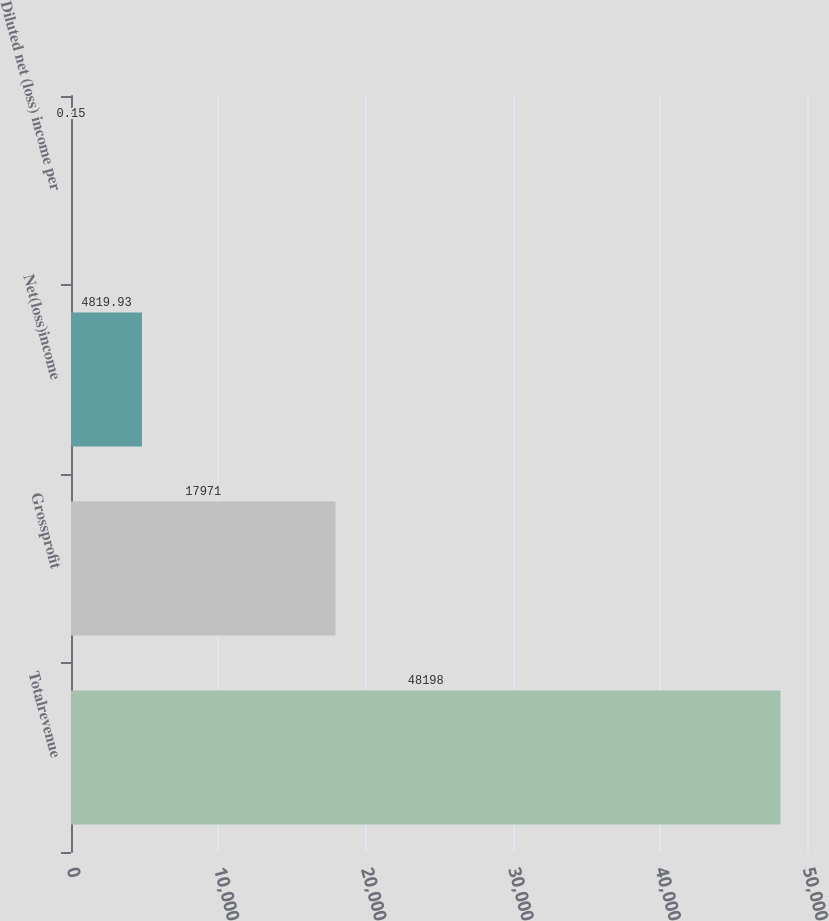<chart> <loc_0><loc_0><loc_500><loc_500><bar_chart><fcel>Totalrevenue<fcel>Grossprofit<fcel>Net(loss)income<fcel>Diluted net (loss) income per<nl><fcel>48198<fcel>17971<fcel>4819.93<fcel>0.15<nl></chart> 